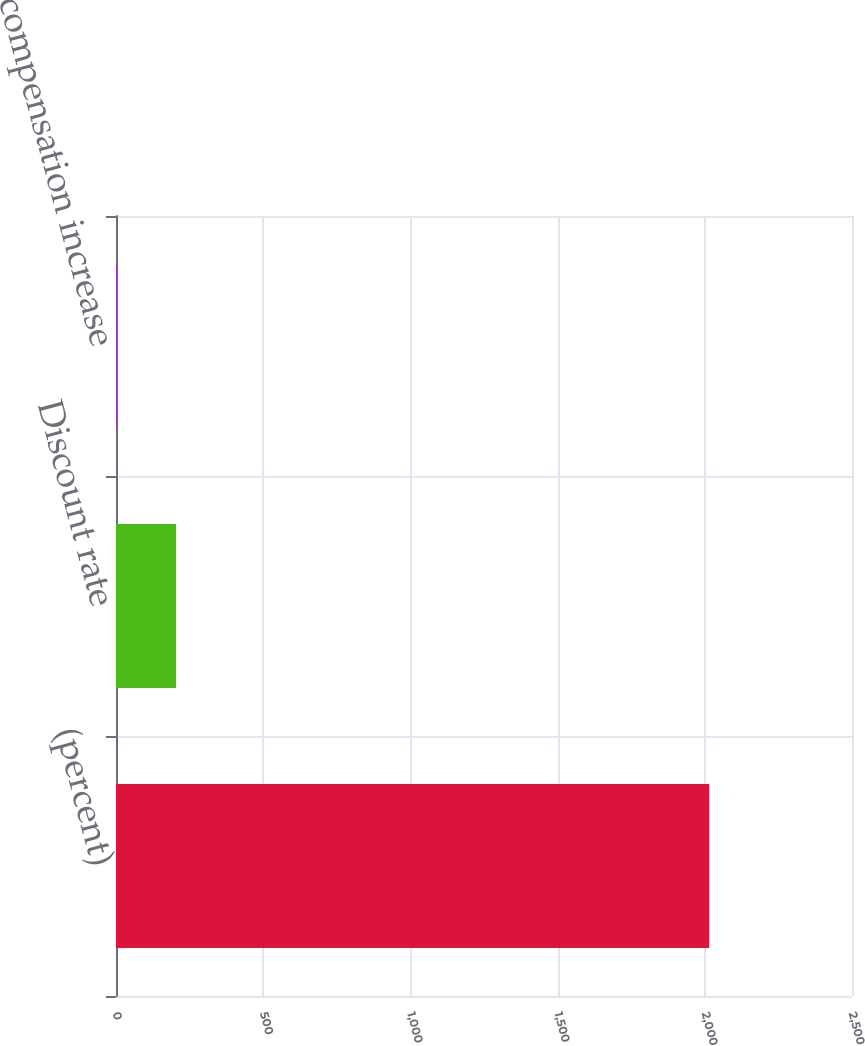Convert chart. <chart><loc_0><loc_0><loc_500><loc_500><bar_chart><fcel>(percent)<fcel>Discount rate<fcel>Rate of compensation increase<nl><fcel>2015<fcel>204.21<fcel>3.01<nl></chart> 